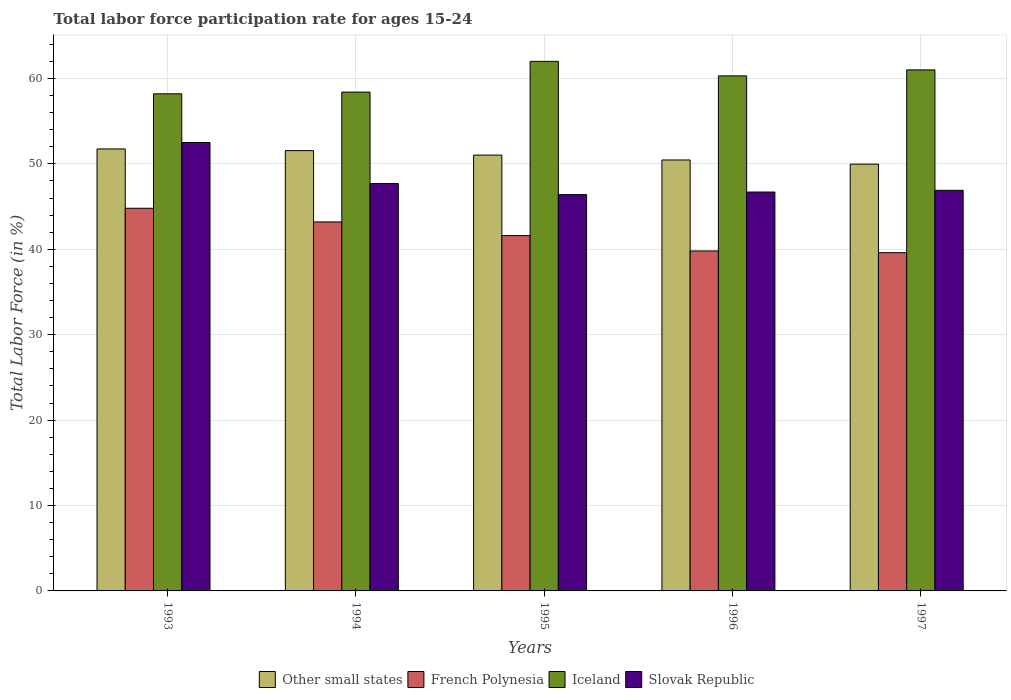How many groups of bars are there?
Your answer should be compact. 5. Are the number of bars per tick equal to the number of legend labels?
Give a very brief answer. Yes. How many bars are there on the 2nd tick from the right?
Provide a short and direct response. 4. In how many cases, is the number of bars for a given year not equal to the number of legend labels?
Offer a terse response. 0. What is the labor force participation rate in Slovak Republic in 1993?
Keep it short and to the point. 52.5. Across all years, what is the maximum labor force participation rate in Slovak Republic?
Your answer should be compact. 52.5. Across all years, what is the minimum labor force participation rate in Other small states?
Keep it short and to the point. 49.97. In which year was the labor force participation rate in Iceland maximum?
Provide a short and direct response. 1995. What is the total labor force participation rate in Iceland in the graph?
Your answer should be very brief. 299.9. What is the difference between the labor force participation rate in Iceland in 1994 and that in 1996?
Offer a terse response. -1.9. What is the average labor force participation rate in Iceland per year?
Make the answer very short. 59.98. In the year 1995, what is the difference between the labor force participation rate in Iceland and labor force participation rate in French Polynesia?
Make the answer very short. 20.4. In how many years, is the labor force participation rate in Other small states greater than 8 %?
Your answer should be compact. 5. What is the ratio of the labor force participation rate in Slovak Republic in 1994 to that in 1997?
Provide a succinct answer. 1.02. Is the difference between the labor force participation rate in Iceland in 1993 and 1997 greater than the difference between the labor force participation rate in French Polynesia in 1993 and 1997?
Offer a very short reply. No. What is the difference between the highest and the second highest labor force participation rate in Slovak Republic?
Provide a short and direct response. 4.8. What is the difference between the highest and the lowest labor force participation rate in French Polynesia?
Offer a very short reply. 5.2. In how many years, is the labor force participation rate in Iceland greater than the average labor force participation rate in Iceland taken over all years?
Your response must be concise. 3. What does the 4th bar from the left in 1994 represents?
Offer a terse response. Slovak Republic. What does the 2nd bar from the right in 1996 represents?
Your response must be concise. Iceland. How many bars are there?
Your answer should be compact. 20. Are all the bars in the graph horizontal?
Give a very brief answer. No. What is the difference between two consecutive major ticks on the Y-axis?
Provide a succinct answer. 10. Does the graph contain any zero values?
Offer a terse response. No. Does the graph contain grids?
Give a very brief answer. Yes. Where does the legend appear in the graph?
Your answer should be very brief. Bottom center. How many legend labels are there?
Give a very brief answer. 4. What is the title of the graph?
Offer a terse response. Total labor force participation rate for ages 15-24. What is the label or title of the X-axis?
Offer a terse response. Years. What is the Total Labor Force (in %) in Other small states in 1993?
Give a very brief answer. 51.74. What is the Total Labor Force (in %) in French Polynesia in 1993?
Offer a very short reply. 44.8. What is the Total Labor Force (in %) of Iceland in 1993?
Provide a short and direct response. 58.2. What is the Total Labor Force (in %) of Slovak Republic in 1993?
Keep it short and to the point. 52.5. What is the Total Labor Force (in %) of Other small states in 1994?
Your answer should be very brief. 51.55. What is the Total Labor Force (in %) in French Polynesia in 1994?
Give a very brief answer. 43.2. What is the Total Labor Force (in %) in Iceland in 1994?
Offer a terse response. 58.4. What is the Total Labor Force (in %) of Slovak Republic in 1994?
Ensure brevity in your answer.  47.7. What is the Total Labor Force (in %) in Other small states in 1995?
Provide a succinct answer. 51.03. What is the Total Labor Force (in %) of French Polynesia in 1995?
Keep it short and to the point. 41.6. What is the Total Labor Force (in %) in Iceland in 1995?
Offer a very short reply. 62. What is the Total Labor Force (in %) in Slovak Republic in 1995?
Your answer should be compact. 46.4. What is the Total Labor Force (in %) of Other small states in 1996?
Offer a terse response. 50.45. What is the Total Labor Force (in %) of French Polynesia in 1996?
Give a very brief answer. 39.8. What is the Total Labor Force (in %) in Iceland in 1996?
Give a very brief answer. 60.3. What is the Total Labor Force (in %) of Slovak Republic in 1996?
Provide a succinct answer. 46.7. What is the Total Labor Force (in %) in Other small states in 1997?
Make the answer very short. 49.97. What is the Total Labor Force (in %) in French Polynesia in 1997?
Your answer should be very brief. 39.6. What is the Total Labor Force (in %) of Iceland in 1997?
Make the answer very short. 61. What is the Total Labor Force (in %) of Slovak Republic in 1997?
Ensure brevity in your answer.  46.9. Across all years, what is the maximum Total Labor Force (in %) of Other small states?
Make the answer very short. 51.74. Across all years, what is the maximum Total Labor Force (in %) of French Polynesia?
Your answer should be compact. 44.8. Across all years, what is the maximum Total Labor Force (in %) of Iceland?
Offer a very short reply. 62. Across all years, what is the maximum Total Labor Force (in %) of Slovak Republic?
Ensure brevity in your answer.  52.5. Across all years, what is the minimum Total Labor Force (in %) in Other small states?
Ensure brevity in your answer.  49.97. Across all years, what is the minimum Total Labor Force (in %) in French Polynesia?
Ensure brevity in your answer.  39.6. Across all years, what is the minimum Total Labor Force (in %) in Iceland?
Offer a very short reply. 58.2. Across all years, what is the minimum Total Labor Force (in %) in Slovak Republic?
Provide a succinct answer. 46.4. What is the total Total Labor Force (in %) of Other small states in the graph?
Your answer should be very brief. 254.74. What is the total Total Labor Force (in %) in French Polynesia in the graph?
Make the answer very short. 209. What is the total Total Labor Force (in %) in Iceland in the graph?
Your answer should be very brief. 299.9. What is the total Total Labor Force (in %) of Slovak Republic in the graph?
Offer a very short reply. 240.2. What is the difference between the Total Labor Force (in %) of Other small states in 1993 and that in 1994?
Give a very brief answer. 0.19. What is the difference between the Total Labor Force (in %) in Slovak Republic in 1993 and that in 1994?
Make the answer very short. 4.8. What is the difference between the Total Labor Force (in %) in Other small states in 1993 and that in 1995?
Offer a terse response. 0.72. What is the difference between the Total Labor Force (in %) of Slovak Republic in 1993 and that in 1995?
Provide a short and direct response. 6.1. What is the difference between the Total Labor Force (in %) of Other small states in 1993 and that in 1996?
Offer a very short reply. 1.29. What is the difference between the Total Labor Force (in %) in Iceland in 1993 and that in 1996?
Give a very brief answer. -2.1. What is the difference between the Total Labor Force (in %) of Slovak Republic in 1993 and that in 1996?
Provide a short and direct response. 5.8. What is the difference between the Total Labor Force (in %) of Other small states in 1993 and that in 1997?
Offer a very short reply. 1.78. What is the difference between the Total Labor Force (in %) in Slovak Republic in 1993 and that in 1997?
Give a very brief answer. 5.6. What is the difference between the Total Labor Force (in %) of Other small states in 1994 and that in 1995?
Your answer should be very brief. 0.52. What is the difference between the Total Labor Force (in %) of Iceland in 1994 and that in 1995?
Offer a terse response. -3.6. What is the difference between the Total Labor Force (in %) in Other small states in 1994 and that in 1996?
Give a very brief answer. 1.1. What is the difference between the Total Labor Force (in %) of French Polynesia in 1994 and that in 1996?
Offer a very short reply. 3.4. What is the difference between the Total Labor Force (in %) of Slovak Republic in 1994 and that in 1996?
Your answer should be compact. 1. What is the difference between the Total Labor Force (in %) of Other small states in 1994 and that in 1997?
Your response must be concise. 1.58. What is the difference between the Total Labor Force (in %) of French Polynesia in 1994 and that in 1997?
Offer a very short reply. 3.6. What is the difference between the Total Labor Force (in %) of Iceland in 1994 and that in 1997?
Offer a very short reply. -2.6. What is the difference between the Total Labor Force (in %) in Slovak Republic in 1994 and that in 1997?
Your answer should be very brief. 0.8. What is the difference between the Total Labor Force (in %) in Other small states in 1995 and that in 1996?
Ensure brevity in your answer.  0.57. What is the difference between the Total Labor Force (in %) of Other small states in 1995 and that in 1997?
Give a very brief answer. 1.06. What is the difference between the Total Labor Force (in %) in Slovak Republic in 1995 and that in 1997?
Provide a succinct answer. -0.5. What is the difference between the Total Labor Force (in %) in Other small states in 1996 and that in 1997?
Keep it short and to the point. 0.49. What is the difference between the Total Labor Force (in %) in French Polynesia in 1996 and that in 1997?
Provide a short and direct response. 0.2. What is the difference between the Total Labor Force (in %) of Slovak Republic in 1996 and that in 1997?
Offer a very short reply. -0.2. What is the difference between the Total Labor Force (in %) of Other small states in 1993 and the Total Labor Force (in %) of French Polynesia in 1994?
Give a very brief answer. 8.54. What is the difference between the Total Labor Force (in %) of Other small states in 1993 and the Total Labor Force (in %) of Iceland in 1994?
Provide a short and direct response. -6.66. What is the difference between the Total Labor Force (in %) of Other small states in 1993 and the Total Labor Force (in %) of Slovak Republic in 1994?
Offer a terse response. 4.04. What is the difference between the Total Labor Force (in %) of Iceland in 1993 and the Total Labor Force (in %) of Slovak Republic in 1994?
Make the answer very short. 10.5. What is the difference between the Total Labor Force (in %) of Other small states in 1993 and the Total Labor Force (in %) of French Polynesia in 1995?
Ensure brevity in your answer.  10.14. What is the difference between the Total Labor Force (in %) of Other small states in 1993 and the Total Labor Force (in %) of Iceland in 1995?
Ensure brevity in your answer.  -10.26. What is the difference between the Total Labor Force (in %) in Other small states in 1993 and the Total Labor Force (in %) in Slovak Republic in 1995?
Make the answer very short. 5.34. What is the difference between the Total Labor Force (in %) of French Polynesia in 1993 and the Total Labor Force (in %) of Iceland in 1995?
Offer a terse response. -17.2. What is the difference between the Total Labor Force (in %) of French Polynesia in 1993 and the Total Labor Force (in %) of Slovak Republic in 1995?
Ensure brevity in your answer.  -1.6. What is the difference between the Total Labor Force (in %) in Other small states in 1993 and the Total Labor Force (in %) in French Polynesia in 1996?
Your answer should be compact. 11.94. What is the difference between the Total Labor Force (in %) of Other small states in 1993 and the Total Labor Force (in %) of Iceland in 1996?
Provide a short and direct response. -8.56. What is the difference between the Total Labor Force (in %) of Other small states in 1993 and the Total Labor Force (in %) of Slovak Republic in 1996?
Your answer should be very brief. 5.04. What is the difference between the Total Labor Force (in %) of French Polynesia in 1993 and the Total Labor Force (in %) of Iceland in 1996?
Provide a succinct answer. -15.5. What is the difference between the Total Labor Force (in %) in French Polynesia in 1993 and the Total Labor Force (in %) in Slovak Republic in 1996?
Offer a very short reply. -1.9. What is the difference between the Total Labor Force (in %) in Iceland in 1993 and the Total Labor Force (in %) in Slovak Republic in 1996?
Give a very brief answer. 11.5. What is the difference between the Total Labor Force (in %) of Other small states in 1993 and the Total Labor Force (in %) of French Polynesia in 1997?
Provide a short and direct response. 12.14. What is the difference between the Total Labor Force (in %) in Other small states in 1993 and the Total Labor Force (in %) in Iceland in 1997?
Provide a succinct answer. -9.26. What is the difference between the Total Labor Force (in %) in Other small states in 1993 and the Total Labor Force (in %) in Slovak Republic in 1997?
Provide a succinct answer. 4.84. What is the difference between the Total Labor Force (in %) in French Polynesia in 1993 and the Total Labor Force (in %) in Iceland in 1997?
Ensure brevity in your answer.  -16.2. What is the difference between the Total Labor Force (in %) of French Polynesia in 1993 and the Total Labor Force (in %) of Slovak Republic in 1997?
Your answer should be very brief. -2.1. What is the difference between the Total Labor Force (in %) in Other small states in 1994 and the Total Labor Force (in %) in French Polynesia in 1995?
Keep it short and to the point. 9.95. What is the difference between the Total Labor Force (in %) in Other small states in 1994 and the Total Labor Force (in %) in Iceland in 1995?
Your answer should be compact. -10.45. What is the difference between the Total Labor Force (in %) of Other small states in 1994 and the Total Labor Force (in %) of Slovak Republic in 1995?
Give a very brief answer. 5.15. What is the difference between the Total Labor Force (in %) of French Polynesia in 1994 and the Total Labor Force (in %) of Iceland in 1995?
Keep it short and to the point. -18.8. What is the difference between the Total Labor Force (in %) in French Polynesia in 1994 and the Total Labor Force (in %) in Slovak Republic in 1995?
Keep it short and to the point. -3.2. What is the difference between the Total Labor Force (in %) of Other small states in 1994 and the Total Labor Force (in %) of French Polynesia in 1996?
Your answer should be very brief. 11.75. What is the difference between the Total Labor Force (in %) in Other small states in 1994 and the Total Labor Force (in %) in Iceland in 1996?
Your answer should be compact. -8.75. What is the difference between the Total Labor Force (in %) in Other small states in 1994 and the Total Labor Force (in %) in Slovak Republic in 1996?
Your answer should be compact. 4.85. What is the difference between the Total Labor Force (in %) in French Polynesia in 1994 and the Total Labor Force (in %) in Iceland in 1996?
Provide a short and direct response. -17.1. What is the difference between the Total Labor Force (in %) in Iceland in 1994 and the Total Labor Force (in %) in Slovak Republic in 1996?
Offer a very short reply. 11.7. What is the difference between the Total Labor Force (in %) of Other small states in 1994 and the Total Labor Force (in %) of French Polynesia in 1997?
Your answer should be very brief. 11.95. What is the difference between the Total Labor Force (in %) in Other small states in 1994 and the Total Labor Force (in %) in Iceland in 1997?
Give a very brief answer. -9.45. What is the difference between the Total Labor Force (in %) in Other small states in 1994 and the Total Labor Force (in %) in Slovak Republic in 1997?
Offer a terse response. 4.65. What is the difference between the Total Labor Force (in %) of French Polynesia in 1994 and the Total Labor Force (in %) of Iceland in 1997?
Ensure brevity in your answer.  -17.8. What is the difference between the Total Labor Force (in %) in French Polynesia in 1994 and the Total Labor Force (in %) in Slovak Republic in 1997?
Offer a terse response. -3.7. What is the difference between the Total Labor Force (in %) of Iceland in 1994 and the Total Labor Force (in %) of Slovak Republic in 1997?
Give a very brief answer. 11.5. What is the difference between the Total Labor Force (in %) in Other small states in 1995 and the Total Labor Force (in %) in French Polynesia in 1996?
Your response must be concise. 11.23. What is the difference between the Total Labor Force (in %) in Other small states in 1995 and the Total Labor Force (in %) in Iceland in 1996?
Keep it short and to the point. -9.27. What is the difference between the Total Labor Force (in %) of Other small states in 1995 and the Total Labor Force (in %) of Slovak Republic in 1996?
Your response must be concise. 4.33. What is the difference between the Total Labor Force (in %) in French Polynesia in 1995 and the Total Labor Force (in %) in Iceland in 1996?
Offer a very short reply. -18.7. What is the difference between the Total Labor Force (in %) in French Polynesia in 1995 and the Total Labor Force (in %) in Slovak Republic in 1996?
Provide a short and direct response. -5.1. What is the difference between the Total Labor Force (in %) in Iceland in 1995 and the Total Labor Force (in %) in Slovak Republic in 1996?
Your response must be concise. 15.3. What is the difference between the Total Labor Force (in %) of Other small states in 1995 and the Total Labor Force (in %) of French Polynesia in 1997?
Your answer should be compact. 11.43. What is the difference between the Total Labor Force (in %) of Other small states in 1995 and the Total Labor Force (in %) of Iceland in 1997?
Offer a very short reply. -9.97. What is the difference between the Total Labor Force (in %) of Other small states in 1995 and the Total Labor Force (in %) of Slovak Republic in 1997?
Offer a terse response. 4.13. What is the difference between the Total Labor Force (in %) in French Polynesia in 1995 and the Total Labor Force (in %) in Iceland in 1997?
Make the answer very short. -19.4. What is the difference between the Total Labor Force (in %) of Iceland in 1995 and the Total Labor Force (in %) of Slovak Republic in 1997?
Provide a short and direct response. 15.1. What is the difference between the Total Labor Force (in %) in Other small states in 1996 and the Total Labor Force (in %) in French Polynesia in 1997?
Ensure brevity in your answer.  10.85. What is the difference between the Total Labor Force (in %) in Other small states in 1996 and the Total Labor Force (in %) in Iceland in 1997?
Give a very brief answer. -10.55. What is the difference between the Total Labor Force (in %) in Other small states in 1996 and the Total Labor Force (in %) in Slovak Republic in 1997?
Provide a succinct answer. 3.55. What is the difference between the Total Labor Force (in %) of French Polynesia in 1996 and the Total Labor Force (in %) of Iceland in 1997?
Your response must be concise. -21.2. What is the difference between the Total Labor Force (in %) of Iceland in 1996 and the Total Labor Force (in %) of Slovak Republic in 1997?
Offer a terse response. 13.4. What is the average Total Labor Force (in %) in Other small states per year?
Provide a succinct answer. 50.95. What is the average Total Labor Force (in %) in French Polynesia per year?
Your answer should be very brief. 41.8. What is the average Total Labor Force (in %) in Iceland per year?
Your response must be concise. 59.98. What is the average Total Labor Force (in %) of Slovak Republic per year?
Your answer should be very brief. 48.04. In the year 1993, what is the difference between the Total Labor Force (in %) in Other small states and Total Labor Force (in %) in French Polynesia?
Give a very brief answer. 6.94. In the year 1993, what is the difference between the Total Labor Force (in %) of Other small states and Total Labor Force (in %) of Iceland?
Provide a succinct answer. -6.46. In the year 1993, what is the difference between the Total Labor Force (in %) of Other small states and Total Labor Force (in %) of Slovak Republic?
Give a very brief answer. -0.76. In the year 1993, what is the difference between the Total Labor Force (in %) in French Polynesia and Total Labor Force (in %) in Iceland?
Give a very brief answer. -13.4. In the year 1994, what is the difference between the Total Labor Force (in %) in Other small states and Total Labor Force (in %) in French Polynesia?
Offer a very short reply. 8.35. In the year 1994, what is the difference between the Total Labor Force (in %) in Other small states and Total Labor Force (in %) in Iceland?
Your answer should be compact. -6.85. In the year 1994, what is the difference between the Total Labor Force (in %) in Other small states and Total Labor Force (in %) in Slovak Republic?
Your answer should be very brief. 3.85. In the year 1994, what is the difference between the Total Labor Force (in %) of French Polynesia and Total Labor Force (in %) of Iceland?
Offer a terse response. -15.2. In the year 1994, what is the difference between the Total Labor Force (in %) in Iceland and Total Labor Force (in %) in Slovak Republic?
Your answer should be compact. 10.7. In the year 1995, what is the difference between the Total Labor Force (in %) in Other small states and Total Labor Force (in %) in French Polynesia?
Ensure brevity in your answer.  9.43. In the year 1995, what is the difference between the Total Labor Force (in %) of Other small states and Total Labor Force (in %) of Iceland?
Your answer should be very brief. -10.97. In the year 1995, what is the difference between the Total Labor Force (in %) in Other small states and Total Labor Force (in %) in Slovak Republic?
Provide a short and direct response. 4.63. In the year 1995, what is the difference between the Total Labor Force (in %) of French Polynesia and Total Labor Force (in %) of Iceland?
Your answer should be compact. -20.4. In the year 1995, what is the difference between the Total Labor Force (in %) of French Polynesia and Total Labor Force (in %) of Slovak Republic?
Ensure brevity in your answer.  -4.8. In the year 1995, what is the difference between the Total Labor Force (in %) of Iceland and Total Labor Force (in %) of Slovak Republic?
Keep it short and to the point. 15.6. In the year 1996, what is the difference between the Total Labor Force (in %) in Other small states and Total Labor Force (in %) in French Polynesia?
Keep it short and to the point. 10.65. In the year 1996, what is the difference between the Total Labor Force (in %) in Other small states and Total Labor Force (in %) in Iceland?
Provide a succinct answer. -9.85. In the year 1996, what is the difference between the Total Labor Force (in %) of Other small states and Total Labor Force (in %) of Slovak Republic?
Ensure brevity in your answer.  3.75. In the year 1996, what is the difference between the Total Labor Force (in %) in French Polynesia and Total Labor Force (in %) in Iceland?
Ensure brevity in your answer.  -20.5. In the year 1997, what is the difference between the Total Labor Force (in %) in Other small states and Total Labor Force (in %) in French Polynesia?
Give a very brief answer. 10.37. In the year 1997, what is the difference between the Total Labor Force (in %) in Other small states and Total Labor Force (in %) in Iceland?
Provide a succinct answer. -11.03. In the year 1997, what is the difference between the Total Labor Force (in %) of Other small states and Total Labor Force (in %) of Slovak Republic?
Your response must be concise. 3.07. In the year 1997, what is the difference between the Total Labor Force (in %) of French Polynesia and Total Labor Force (in %) of Iceland?
Ensure brevity in your answer.  -21.4. What is the ratio of the Total Labor Force (in %) of French Polynesia in 1993 to that in 1994?
Make the answer very short. 1.04. What is the ratio of the Total Labor Force (in %) in Iceland in 1993 to that in 1994?
Provide a short and direct response. 1. What is the ratio of the Total Labor Force (in %) in Slovak Republic in 1993 to that in 1994?
Your response must be concise. 1.1. What is the ratio of the Total Labor Force (in %) in Other small states in 1993 to that in 1995?
Offer a very short reply. 1.01. What is the ratio of the Total Labor Force (in %) in Iceland in 1993 to that in 1995?
Offer a terse response. 0.94. What is the ratio of the Total Labor Force (in %) in Slovak Republic in 1993 to that in 1995?
Provide a short and direct response. 1.13. What is the ratio of the Total Labor Force (in %) of Other small states in 1993 to that in 1996?
Ensure brevity in your answer.  1.03. What is the ratio of the Total Labor Force (in %) of French Polynesia in 1993 to that in 1996?
Give a very brief answer. 1.13. What is the ratio of the Total Labor Force (in %) of Iceland in 1993 to that in 1996?
Your response must be concise. 0.97. What is the ratio of the Total Labor Force (in %) in Slovak Republic in 1993 to that in 1996?
Give a very brief answer. 1.12. What is the ratio of the Total Labor Force (in %) of Other small states in 1993 to that in 1997?
Give a very brief answer. 1.04. What is the ratio of the Total Labor Force (in %) of French Polynesia in 1993 to that in 1997?
Your answer should be compact. 1.13. What is the ratio of the Total Labor Force (in %) of Iceland in 1993 to that in 1997?
Your answer should be compact. 0.95. What is the ratio of the Total Labor Force (in %) in Slovak Republic in 1993 to that in 1997?
Offer a very short reply. 1.12. What is the ratio of the Total Labor Force (in %) of Other small states in 1994 to that in 1995?
Give a very brief answer. 1.01. What is the ratio of the Total Labor Force (in %) of French Polynesia in 1994 to that in 1995?
Offer a very short reply. 1.04. What is the ratio of the Total Labor Force (in %) of Iceland in 1994 to that in 1995?
Provide a short and direct response. 0.94. What is the ratio of the Total Labor Force (in %) of Slovak Republic in 1994 to that in 1995?
Provide a succinct answer. 1.03. What is the ratio of the Total Labor Force (in %) in Other small states in 1994 to that in 1996?
Provide a succinct answer. 1.02. What is the ratio of the Total Labor Force (in %) in French Polynesia in 1994 to that in 1996?
Make the answer very short. 1.09. What is the ratio of the Total Labor Force (in %) in Iceland in 1994 to that in 1996?
Give a very brief answer. 0.97. What is the ratio of the Total Labor Force (in %) in Slovak Republic in 1994 to that in 1996?
Offer a terse response. 1.02. What is the ratio of the Total Labor Force (in %) of Other small states in 1994 to that in 1997?
Offer a very short reply. 1.03. What is the ratio of the Total Labor Force (in %) in French Polynesia in 1994 to that in 1997?
Your answer should be very brief. 1.09. What is the ratio of the Total Labor Force (in %) of Iceland in 1994 to that in 1997?
Make the answer very short. 0.96. What is the ratio of the Total Labor Force (in %) of Slovak Republic in 1994 to that in 1997?
Offer a very short reply. 1.02. What is the ratio of the Total Labor Force (in %) of Other small states in 1995 to that in 1996?
Provide a succinct answer. 1.01. What is the ratio of the Total Labor Force (in %) in French Polynesia in 1995 to that in 1996?
Offer a terse response. 1.05. What is the ratio of the Total Labor Force (in %) of Iceland in 1995 to that in 1996?
Provide a short and direct response. 1.03. What is the ratio of the Total Labor Force (in %) in Other small states in 1995 to that in 1997?
Your response must be concise. 1.02. What is the ratio of the Total Labor Force (in %) in French Polynesia in 1995 to that in 1997?
Make the answer very short. 1.05. What is the ratio of the Total Labor Force (in %) in Iceland in 1995 to that in 1997?
Offer a very short reply. 1.02. What is the ratio of the Total Labor Force (in %) in Slovak Republic in 1995 to that in 1997?
Your answer should be very brief. 0.99. What is the ratio of the Total Labor Force (in %) in Other small states in 1996 to that in 1997?
Make the answer very short. 1.01. What is the ratio of the Total Labor Force (in %) of French Polynesia in 1996 to that in 1997?
Make the answer very short. 1.01. What is the difference between the highest and the second highest Total Labor Force (in %) of Other small states?
Make the answer very short. 0.19. What is the difference between the highest and the second highest Total Labor Force (in %) in French Polynesia?
Provide a short and direct response. 1.6. What is the difference between the highest and the second highest Total Labor Force (in %) in Iceland?
Give a very brief answer. 1. What is the difference between the highest and the second highest Total Labor Force (in %) in Slovak Republic?
Make the answer very short. 4.8. What is the difference between the highest and the lowest Total Labor Force (in %) of Other small states?
Your answer should be compact. 1.78. What is the difference between the highest and the lowest Total Labor Force (in %) of Slovak Republic?
Your answer should be compact. 6.1. 